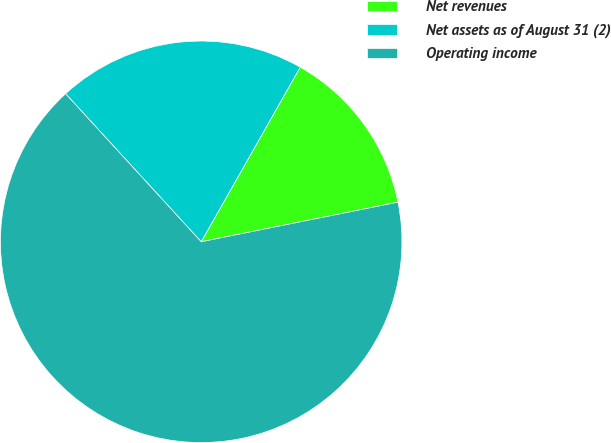Convert chart to OTSL. <chart><loc_0><loc_0><loc_500><loc_500><pie_chart><fcel>Net revenues<fcel>Net assets as of August 31 (2)<fcel>Operating income<nl><fcel>13.63%<fcel>20.01%<fcel>66.36%<nl></chart> 